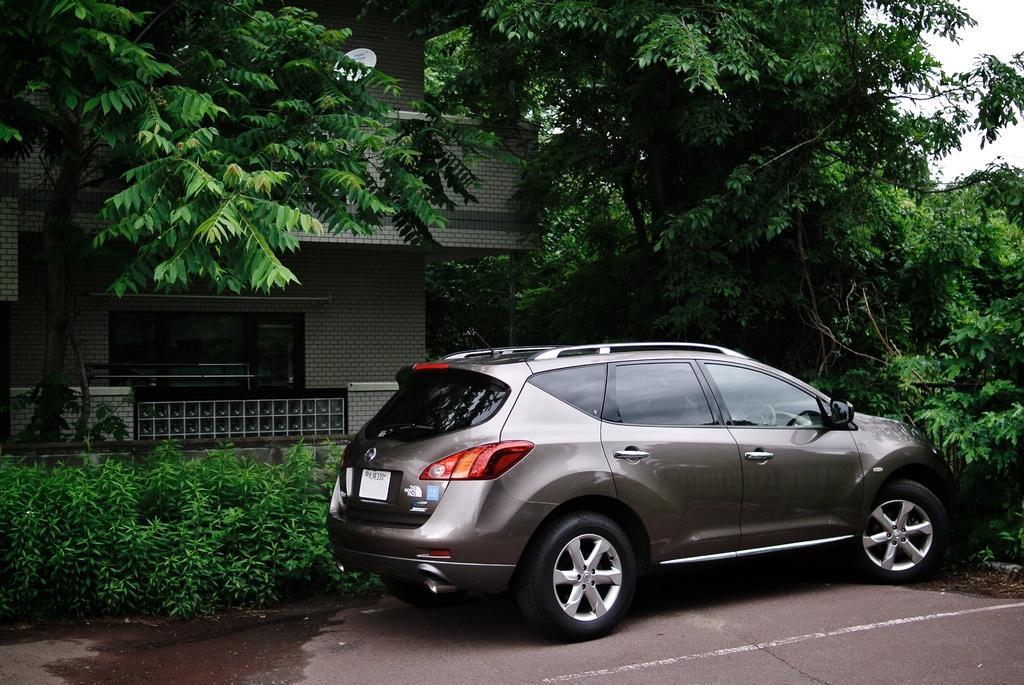Describe this image in one or two sentences. In this image we can see there is a building, car and at the top of the image we can see a dish. There are trees and plants. 